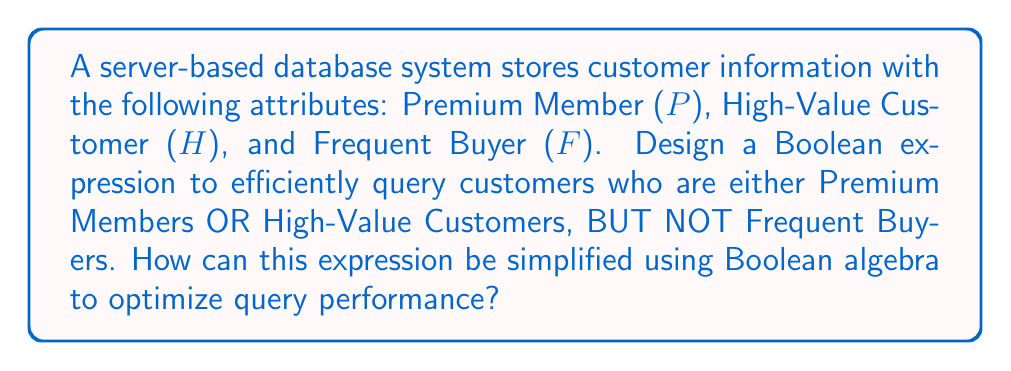Can you answer this question? Let's approach this step-by-step:

1. First, we need to express the query in Boolean terms:
   $$(P \lor H) \land \lnot F$$

2. To simplify this expression, we can apply De Morgan's laws and the distributive property:
   
   $$(P \lor H) \land \lnot F$$
   
   This is already in a relatively simple form, but we can check if further simplification is possible.

3. We can distribute the $\lnot F$ over $(P \lor H)$:
   
   $$(P \land \lnot F) \lor (H \land \lnot F)$$

4. This form, known as the disjunctive normal form (DNF), is often efficient for database queries as it clearly separates the conditions.

5. In terms of query optimization:
   - The original form $$(P \lor H) \land \lnot F$$ requires evaluating $(P \lor H)$ first, then applying $\lnot F$.
   - The DNF form $$(P \land \lnot F) \lor (H \land \lnot F)$$ allows for parallel evaluation of $(P \land \lnot F)$ and $(H \land \lnot F)$.

6. The choice between these forms depends on the specific database system and indexing strategy. If P and H are frequently queried together, the original form might be more efficient. If they are often queried separately, the DNF form could be better.

7. From a cost-effectiveness perspective, the original form $$(P \lor H) \land \lnot F$$ might be slightly more efficient as it requires evaluating $F$ only once, potentially reducing I/O operations.
Answer: $$(P \lor H) \land \lnot F$$ 